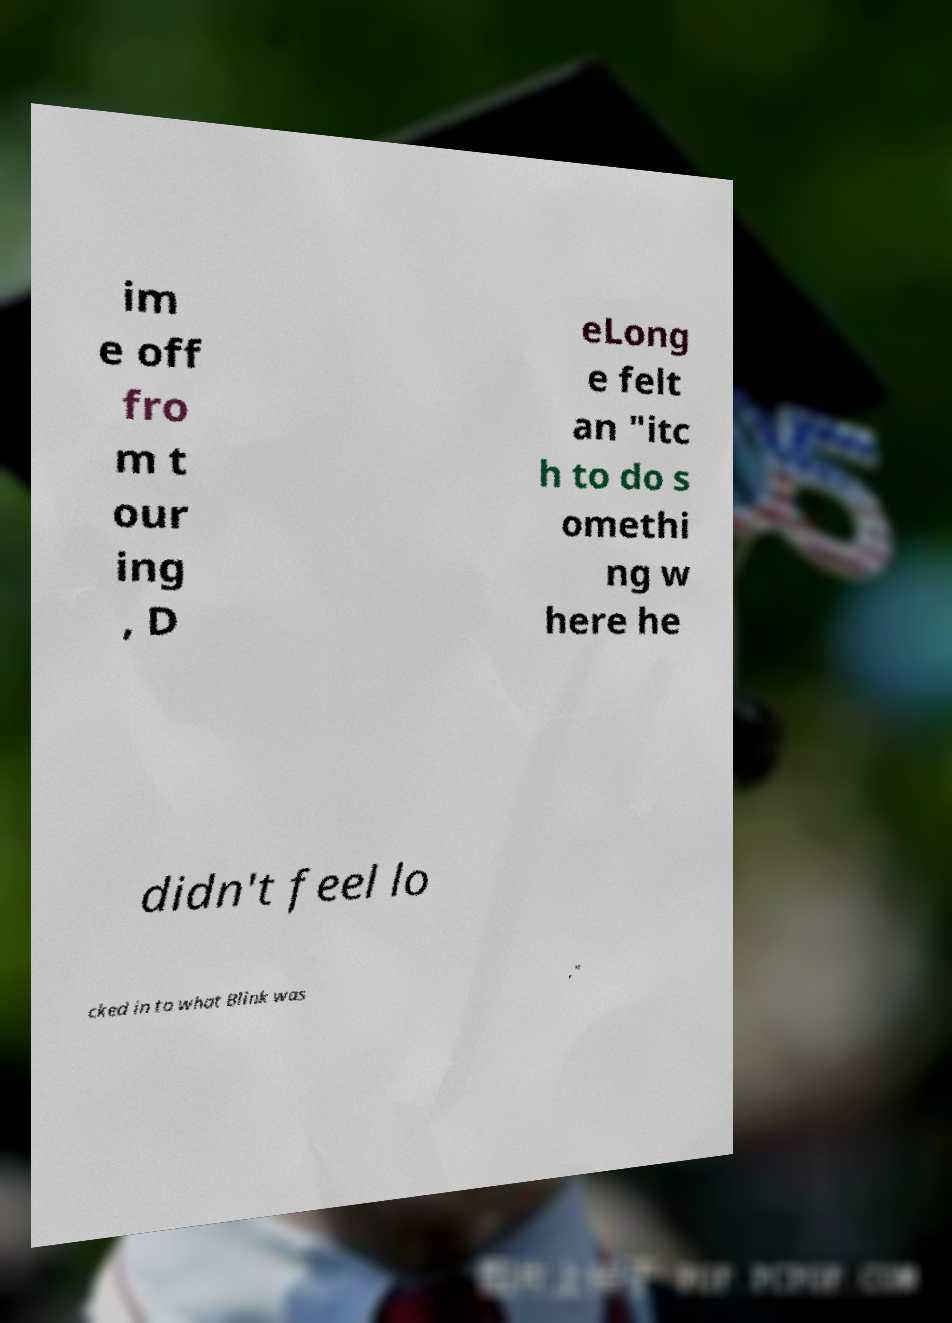Could you assist in decoding the text presented in this image and type it out clearly? im e off fro m t our ing , D eLong e felt an "itc h to do s omethi ng w here he didn't feel lo cked in to what Blink was ," 